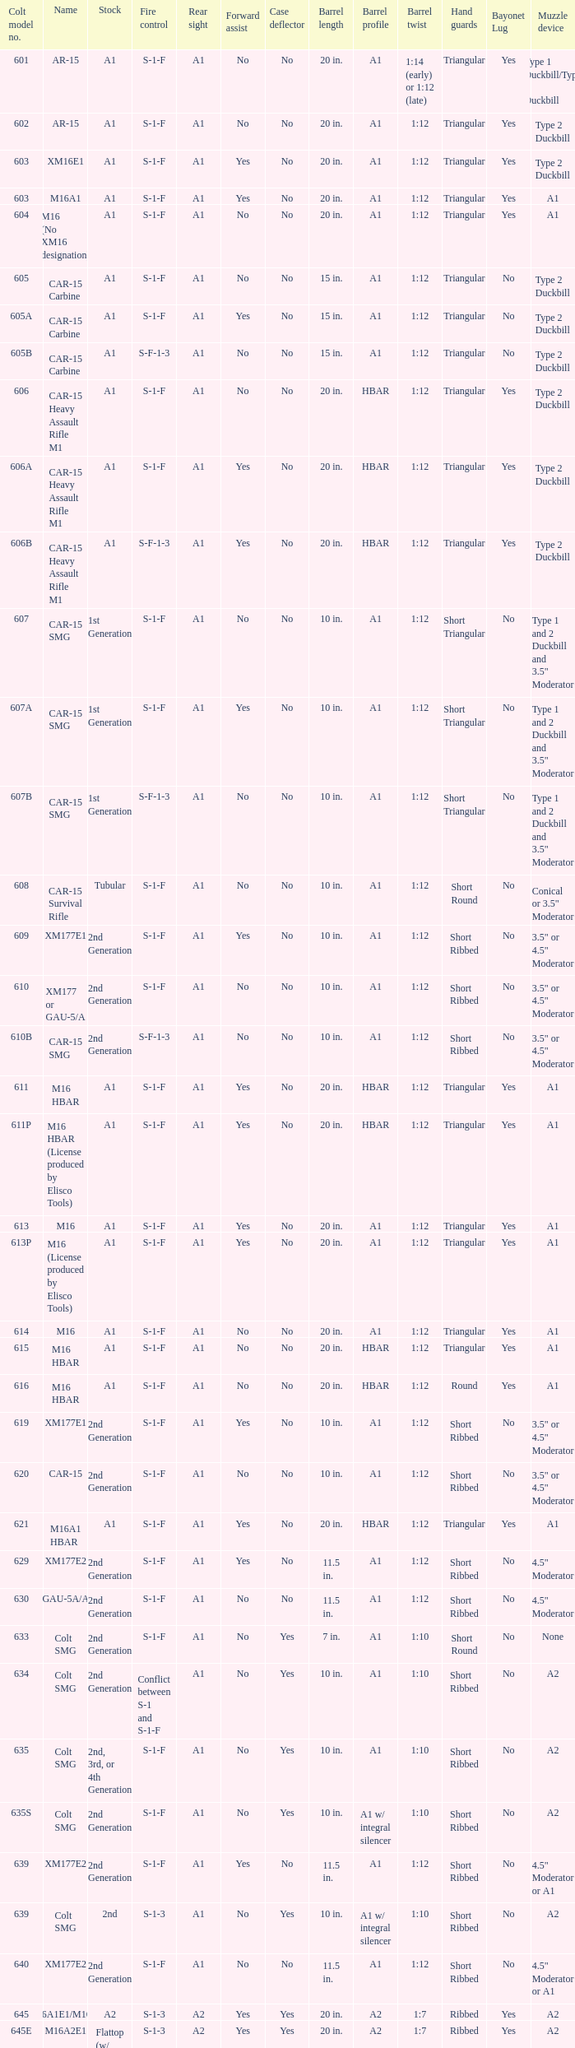What kind of muzzle devices are present on models with circular handguards? A1. 